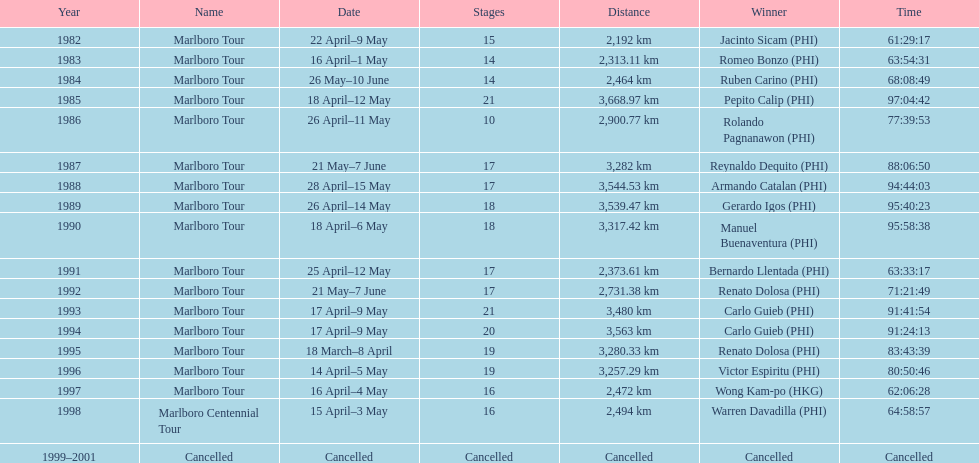What was the aggregate amount of triumphant individuals before the tour was cancelled? 17. Could you help me parse every detail presented in this table? {'header': ['Year', 'Name', 'Date', 'Stages', 'Distance', 'Winner', 'Time'], 'rows': [['1982', 'Marlboro Tour', '22 April–9 May', '15', '2,192\xa0km', 'Jacinto Sicam\xa0(PHI)', '61:29:17'], ['1983', 'Marlboro Tour', '16 April–1 May', '14', '2,313.11\xa0km', 'Romeo Bonzo\xa0(PHI)', '63:54:31'], ['1984', 'Marlboro Tour', '26 May–10 June', '14', '2,464\xa0km', 'Ruben Carino\xa0(PHI)', '68:08:49'], ['1985', 'Marlboro Tour', '18 April–12 May', '21', '3,668.97\xa0km', 'Pepito Calip\xa0(PHI)', '97:04:42'], ['1986', 'Marlboro Tour', '26 April–11 May', '10', '2,900.77\xa0km', 'Rolando Pagnanawon\xa0(PHI)', '77:39:53'], ['1987', 'Marlboro Tour', '21 May–7 June', '17', '3,282\xa0km', 'Reynaldo Dequito\xa0(PHI)', '88:06:50'], ['1988', 'Marlboro Tour', '28 April–15 May', '17', '3,544.53\xa0km', 'Armando Catalan\xa0(PHI)', '94:44:03'], ['1989', 'Marlboro Tour', '26 April–14 May', '18', '3,539.47\xa0km', 'Gerardo Igos\xa0(PHI)', '95:40:23'], ['1990', 'Marlboro Tour', '18 April–6 May', '18', '3,317.42\xa0km', 'Manuel Buenaventura\xa0(PHI)', '95:58:38'], ['1991', 'Marlboro Tour', '25 April–12 May', '17', '2,373.61\xa0km', 'Bernardo Llentada\xa0(PHI)', '63:33:17'], ['1992', 'Marlboro Tour', '21 May–7 June', '17', '2,731.38\xa0km', 'Renato Dolosa\xa0(PHI)', '71:21:49'], ['1993', 'Marlboro Tour', '17 April–9 May', '21', '3,480\xa0km', 'Carlo Guieb\xa0(PHI)', '91:41:54'], ['1994', 'Marlboro Tour', '17 April–9 May', '20', '3,563\xa0km', 'Carlo Guieb\xa0(PHI)', '91:24:13'], ['1995', 'Marlboro Tour', '18 March–8 April', '19', '3,280.33\xa0km', 'Renato Dolosa\xa0(PHI)', '83:43:39'], ['1996', 'Marlboro Tour', '14 April–5 May', '19', '3,257.29\xa0km', 'Victor Espiritu\xa0(PHI)', '80:50:46'], ['1997', 'Marlboro Tour', '16 April–4 May', '16', '2,472\xa0km', 'Wong Kam-po\xa0(HKG)', '62:06:28'], ['1998', 'Marlboro Centennial Tour', '15 April–3 May', '16', '2,494\xa0km', 'Warren Davadilla\xa0(PHI)', '64:58:57'], ['1999–2001', 'Cancelled', 'Cancelled', 'Cancelled', 'Cancelled', 'Cancelled', 'Cancelled']]} 